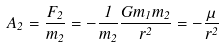Convert formula to latex. <formula><loc_0><loc_0><loc_500><loc_500>A _ { 2 } = { \frac { F _ { 2 } } { m _ { 2 } } } = - { \frac { 1 } { m _ { 2 } } } { \frac { G m _ { 1 } m _ { 2 } } { r ^ { 2 } } } = - { \frac { \mu } { r ^ { 2 } } }</formula> 